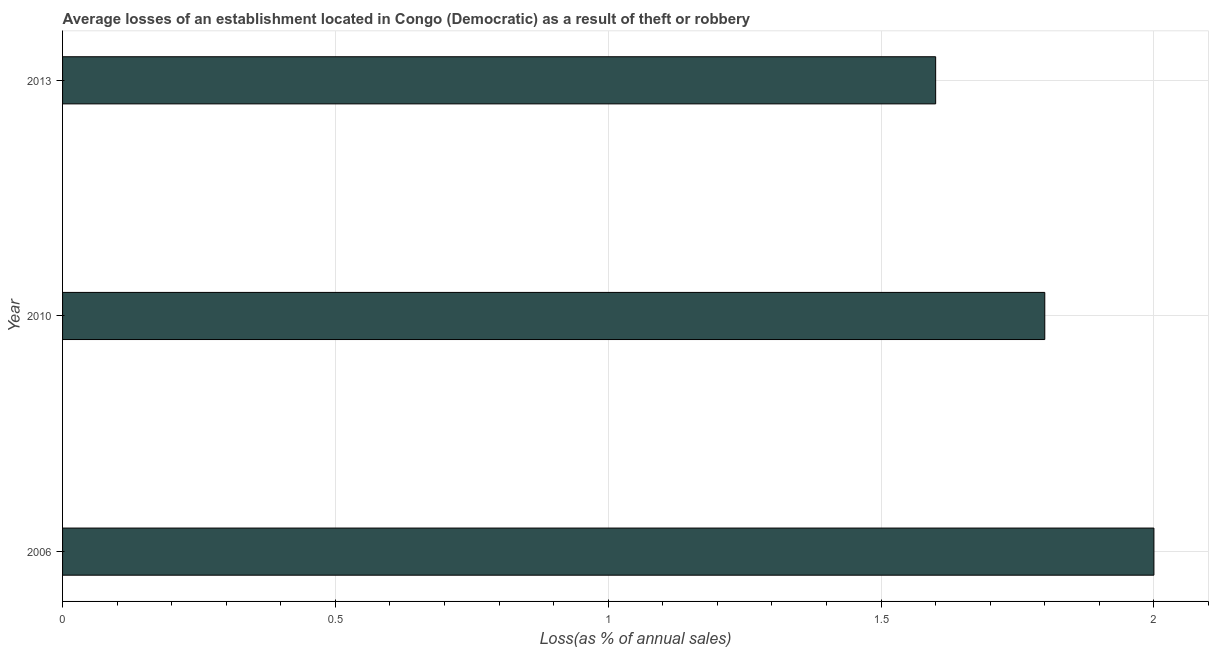What is the title of the graph?
Ensure brevity in your answer.  Average losses of an establishment located in Congo (Democratic) as a result of theft or robbery. What is the label or title of the X-axis?
Ensure brevity in your answer.  Loss(as % of annual sales). What is the label or title of the Y-axis?
Offer a very short reply. Year. What is the losses due to theft in 2013?
Make the answer very short. 1.6. Across all years, what is the maximum losses due to theft?
Your answer should be very brief. 2. Across all years, what is the minimum losses due to theft?
Keep it short and to the point. 1.6. In which year was the losses due to theft maximum?
Your response must be concise. 2006. In which year was the losses due to theft minimum?
Ensure brevity in your answer.  2013. What is the sum of the losses due to theft?
Your answer should be very brief. 5.4. What is the average losses due to theft per year?
Ensure brevity in your answer.  1.8. What is the median losses due to theft?
Give a very brief answer. 1.8. What is the ratio of the losses due to theft in 2006 to that in 2013?
Offer a terse response. 1.25. Is the losses due to theft in 2010 less than that in 2013?
Your response must be concise. No. What is the difference between the highest and the second highest losses due to theft?
Make the answer very short. 0.2. Is the sum of the losses due to theft in 2010 and 2013 greater than the maximum losses due to theft across all years?
Offer a very short reply. Yes. In how many years, is the losses due to theft greater than the average losses due to theft taken over all years?
Offer a terse response. 1. How many bars are there?
Offer a terse response. 3. Are all the bars in the graph horizontal?
Your answer should be very brief. Yes. What is the difference between two consecutive major ticks on the X-axis?
Make the answer very short. 0.5. Are the values on the major ticks of X-axis written in scientific E-notation?
Give a very brief answer. No. What is the Loss(as % of annual sales) in 2006?
Your response must be concise. 2. What is the Loss(as % of annual sales) of 2013?
Your response must be concise. 1.6. What is the ratio of the Loss(as % of annual sales) in 2006 to that in 2010?
Your answer should be very brief. 1.11. What is the ratio of the Loss(as % of annual sales) in 2006 to that in 2013?
Your answer should be compact. 1.25. 